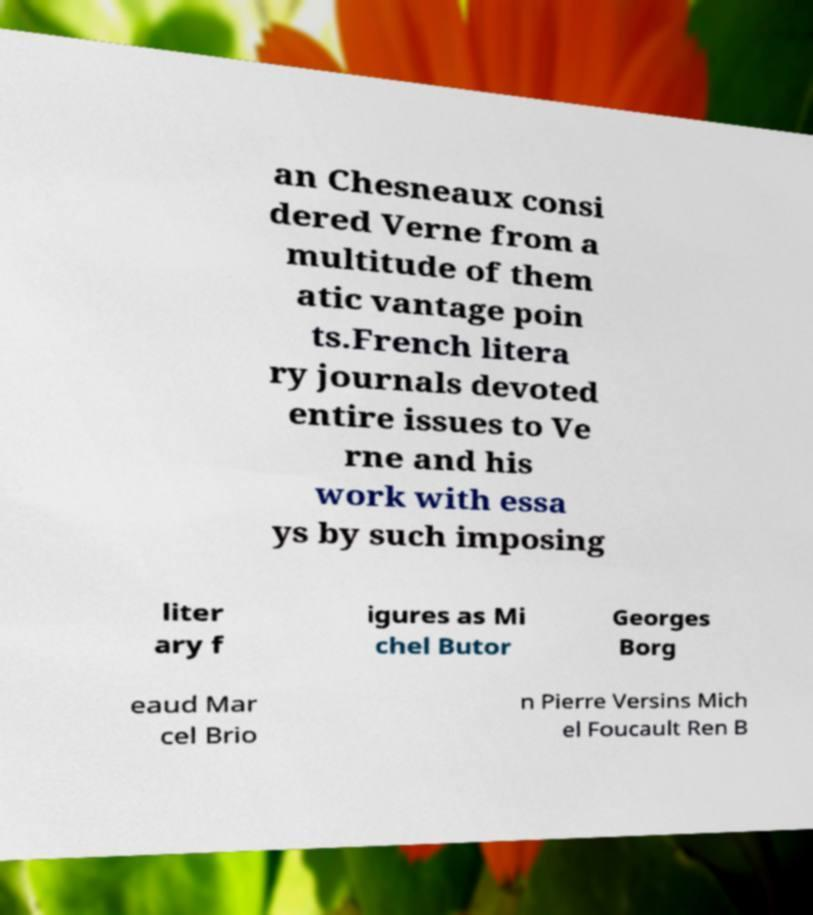What messages or text are displayed in this image? I need them in a readable, typed format. an Chesneaux consi dered Verne from a multitude of them atic vantage poin ts.French litera ry journals devoted entire issues to Ve rne and his work with essa ys by such imposing liter ary f igures as Mi chel Butor Georges Borg eaud Mar cel Brio n Pierre Versins Mich el Foucault Ren B 